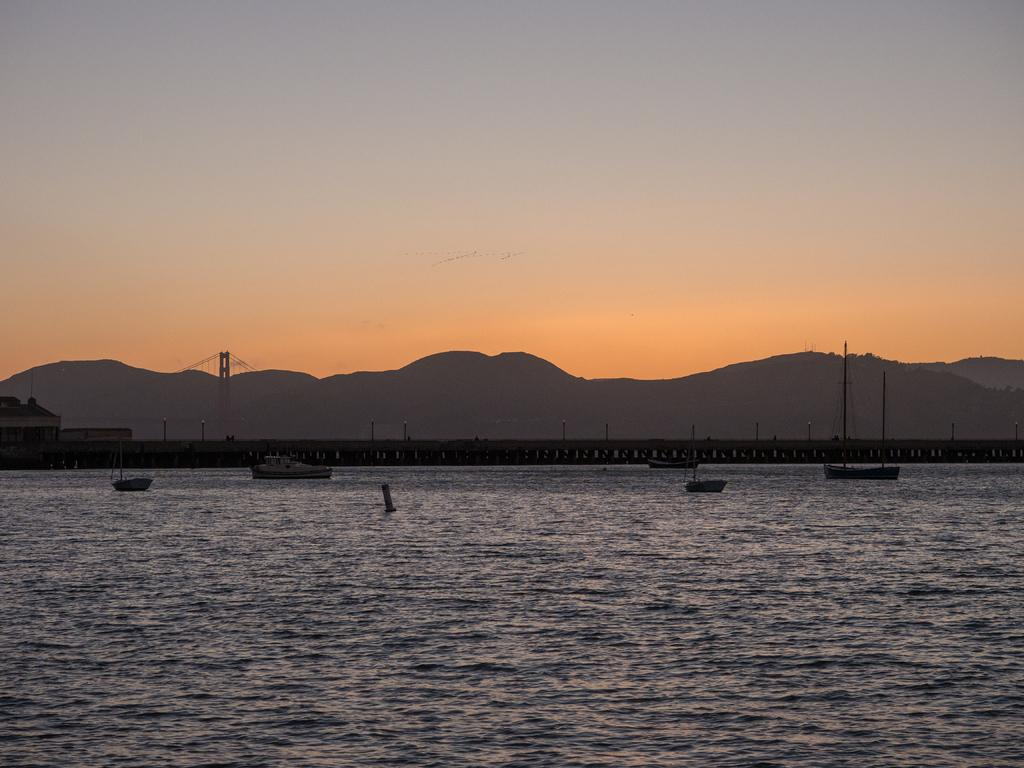What is crossing the river in the image? There is a bridge across the river in the image. What type of structures can be seen in the image? There are buildings and towers in the image. What is present on the water in the image? There are ships and boats on the water in the image. What type of natural feature is visible in the image? There are hills visible in the image. What part of the environment is visible in the image? The sky is visible in the image. Can you see a beam of light shining from the tower in the image? There is no mention of a beam of light in the image; it only states that there are towers present. What type of cracker is being used to request permission to pass through the bridge in the image? There is no mention of a cracker or any request for permission in the image. 